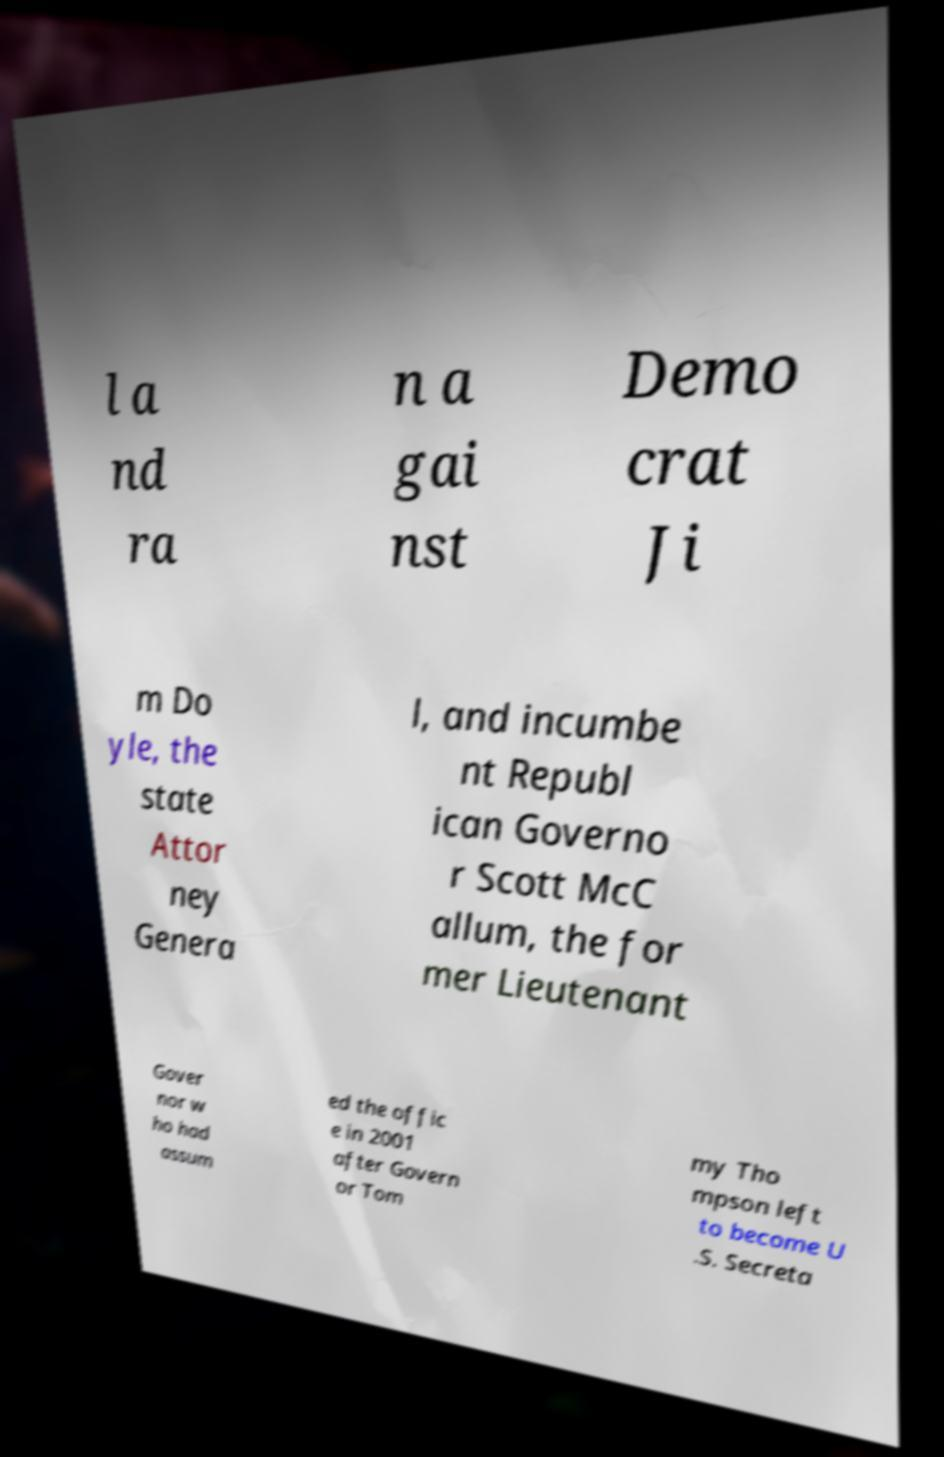I need the written content from this picture converted into text. Can you do that? l a nd ra n a gai nst Demo crat Ji m Do yle, the state Attor ney Genera l, and incumbe nt Republ ican Governo r Scott McC allum, the for mer Lieutenant Gover nor w ho had assum ed the offic e in 2001 after Govern or Tom my Tho mpson left to become U .S. Secreta 